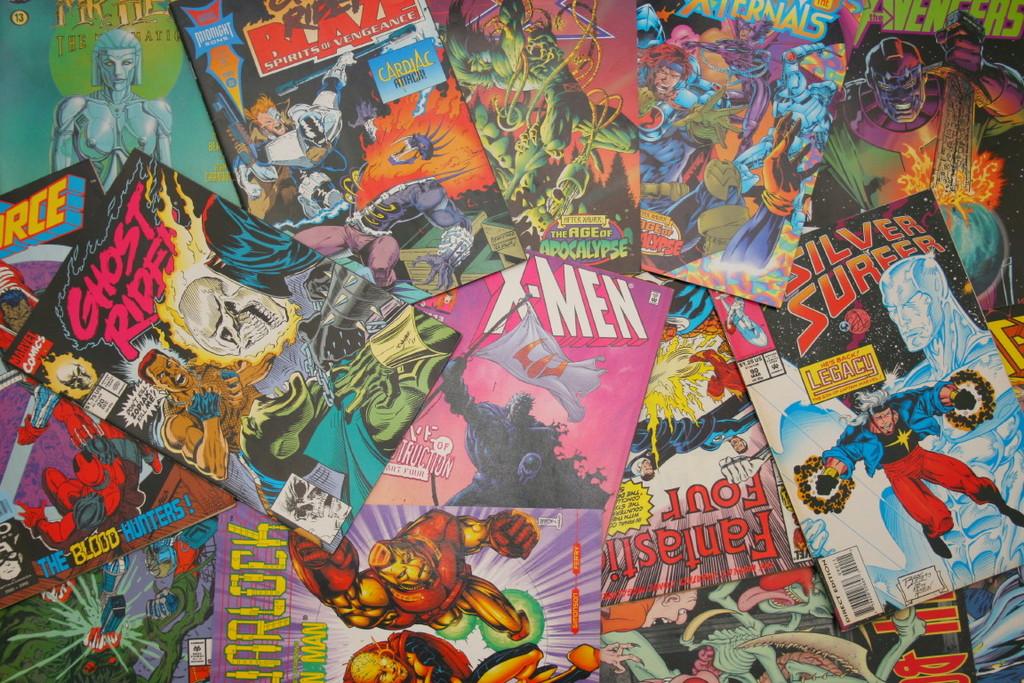What is the name of the comics with picture of the flaming skeleton head?
Offer a very short reply. Ghost rider. What is the name of the purple comic?
Your answer should be very brief. X-men. 